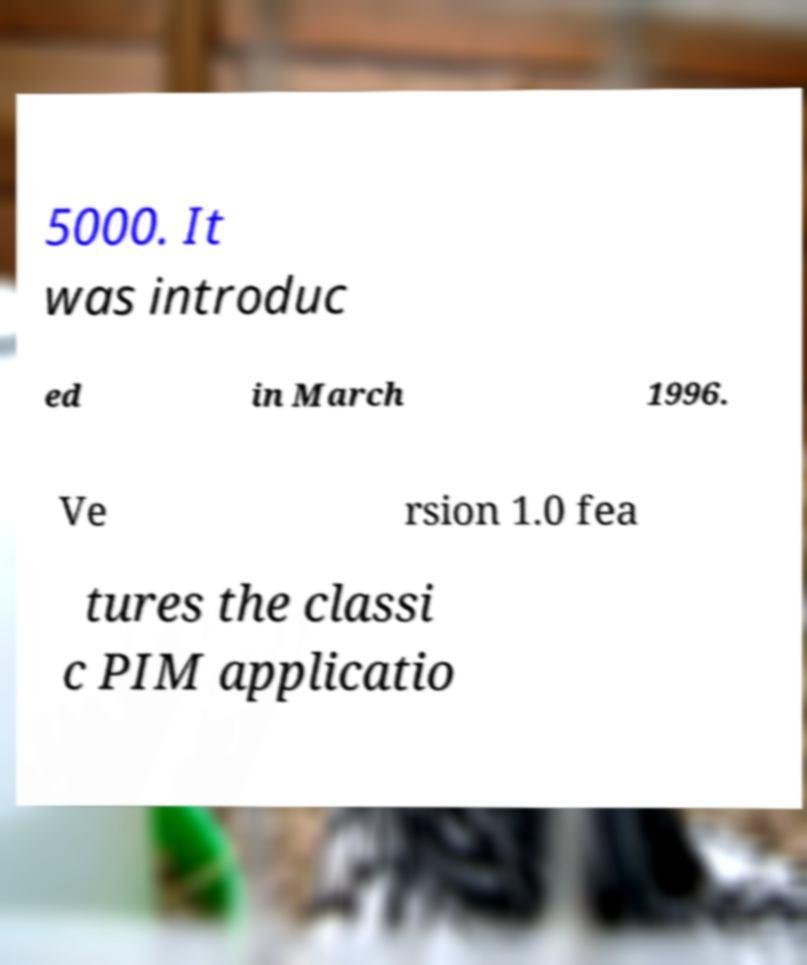Please read and relay the text visible in this image. What does it say? 5000. It was introduc ed in March 1996. Ve rsion 1.0 fea tures the classi c PIM applicatio 